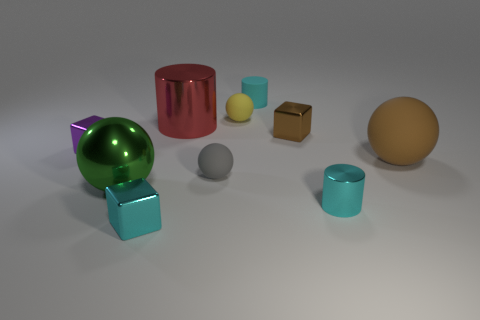How many other things are there of the same shape as the purple thing?
Your answer should be very brief. 2. What number of cubes are left of the tiny cyan metal block?
Your response must be concise. 1. There is a thing that is both behind the brown shiny object and left of the tiny yellow rubber ball; what is its size?
Provide a short and direct response. Large. Is there a tiny red metallic cube?
Your response must be concise. No. How many other things are the same size as the cyan rubber cylinder?
Your answer should be very brief. 6. There is a cylinder that is in front of the brown rubber object; is its color the same as the ball that is behind the big brown matte sphere?
Give a very brief answer. No. The green shiny thing that is the same shape as the small yellow thing is what size?
Give a very brief answer. Large. Does the cyan cylinder to the left of the small shiny cylinder have the same material as the sphere behind the brown matte thing?
Provide a succinct answer. Yes. What number of rubber things are red blocks or tiny brown things?
Keep it short and to the point. 0. What material is the small ball that is in front of the shiny cube that is on the left side of the large ball left of the cyan cube?
Your response must be concise. Rubber. 